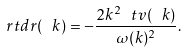<formula> <loc_0><loc_0><loc_500><loc_500>\ r t d r ( \ k ) = - \frac { 2 k ^ { 2 } \ t v ( \ k ) } { \omega ( k ) ^ { 2 } } .</formula> 